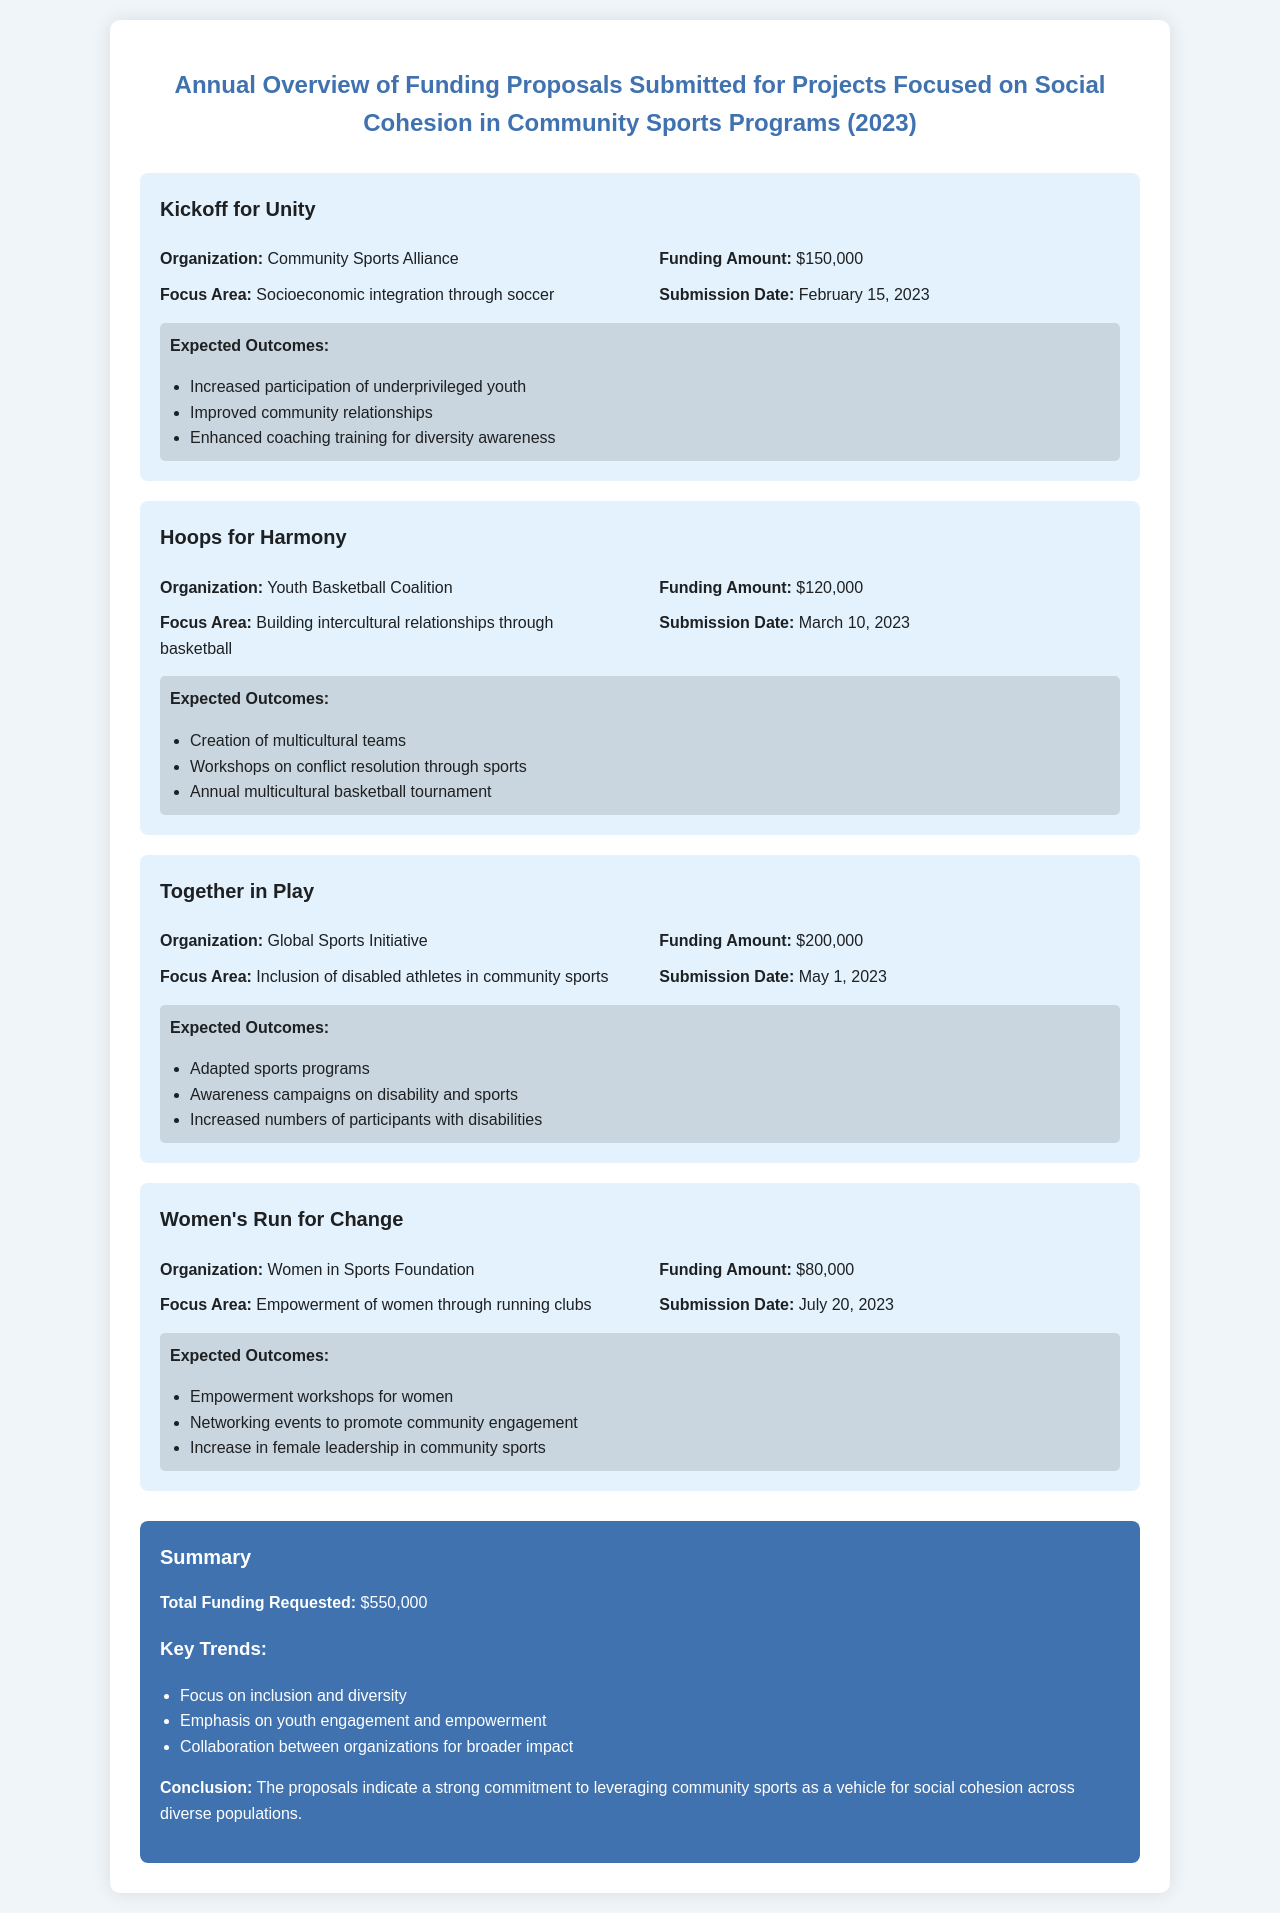what is the title of the document? The title of the document is presented at the top of the rendered webpage, which summarizes the main focus of the content.
Answer: Annual Overview of Funding Proposals Submitted for Projects Focused on Social Cohesion in Community Sports Programs (2023) what is the funding amount for "Kickoff for Unity"? The funding amount for each proposal is specifically listed under the proposal details section for that project.
Answer: $150,000 who submitted the proposal for "Together in Play"? The organization that submitted the proposal is mentioned in the proposal details, providing a clear reference to the responsible entity.
Answer: Global Sports Initiative when was the "Women's Run for Change" proposal submitted? The submission date for each project proposal is included, indicating when the funding request was made.
Answer: July 20, 2023 what is the total funding requested in the summary? The total funding requested is explicitly stated in the summary section, reflecting the overall financial appeal of the proposals.
Answer: $550,000 which focus area is addressed by the proposal "Hoops for Harmony"? The focus area is detailed within the proposals, showing the specific community need each project aims to fulfill.
Answer: Building intercultural relationships through basketball how many expected outcomes are listed for "Together in Play"? The number of expected outcomes is found in the outcomes section for each proposal, providing additional insight into the project's aims.
Answer: 3 what is a key trend highlighted in the summary? Key trends are summarized to reflect the common themes seen across all proposals, helping to identify overarching goals.
Answer: Focus on inclusion and diversity 